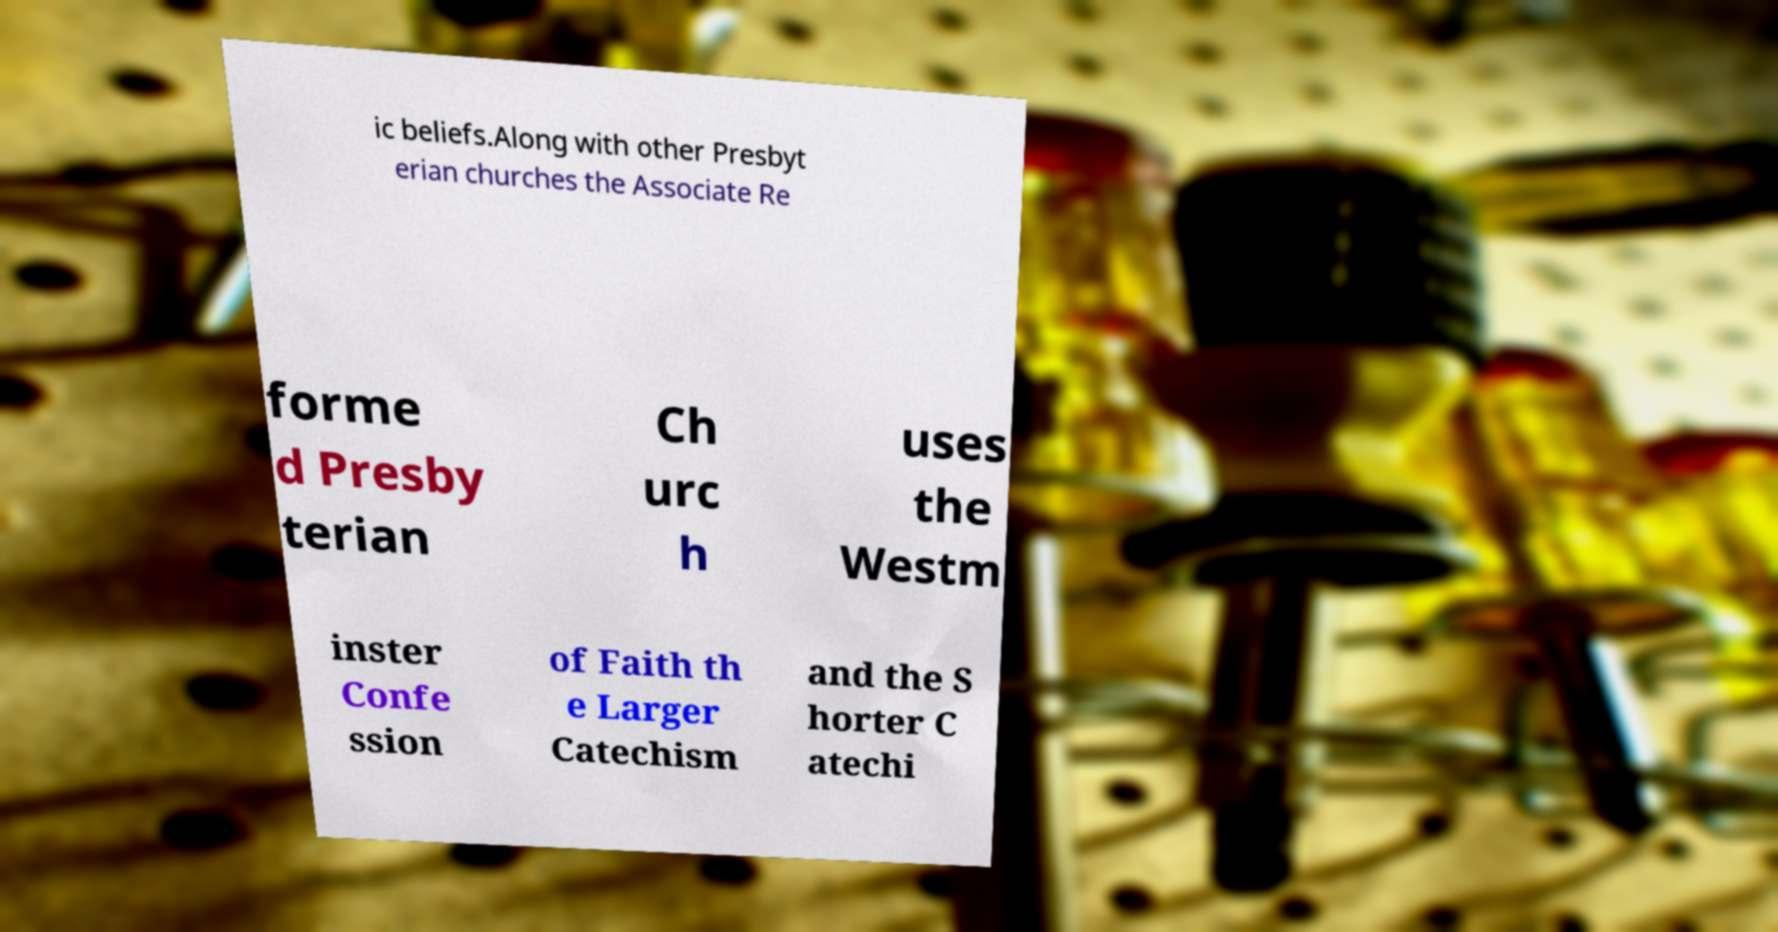Please read and relay the text visible in this image. What does it say? ic beliefs.Along with other Presbyt erian churches the Associate Re forme d Presby terian Ch urc h uses the Westm inster Confe ssion of Faith th e Larger Catechism and the S horter C atechi 